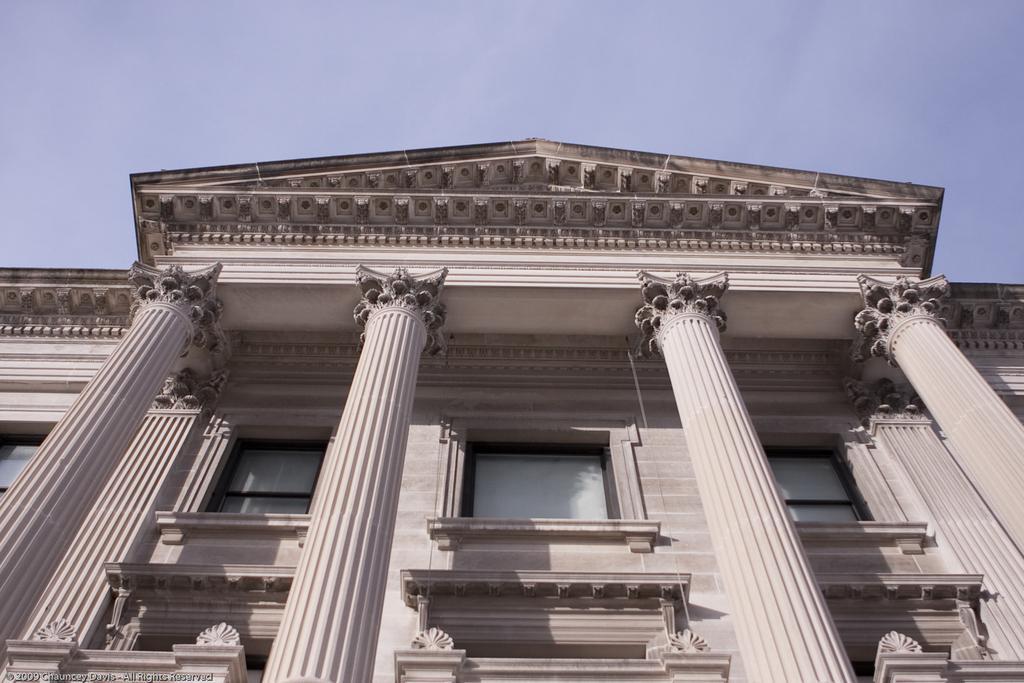Could you give a brief overview of what you see in this image? In the image there is a building and in front of the building there are pillars. 